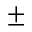<formula> <loc_0><loc_0><loc_500><loc_500>\pm</formula> 